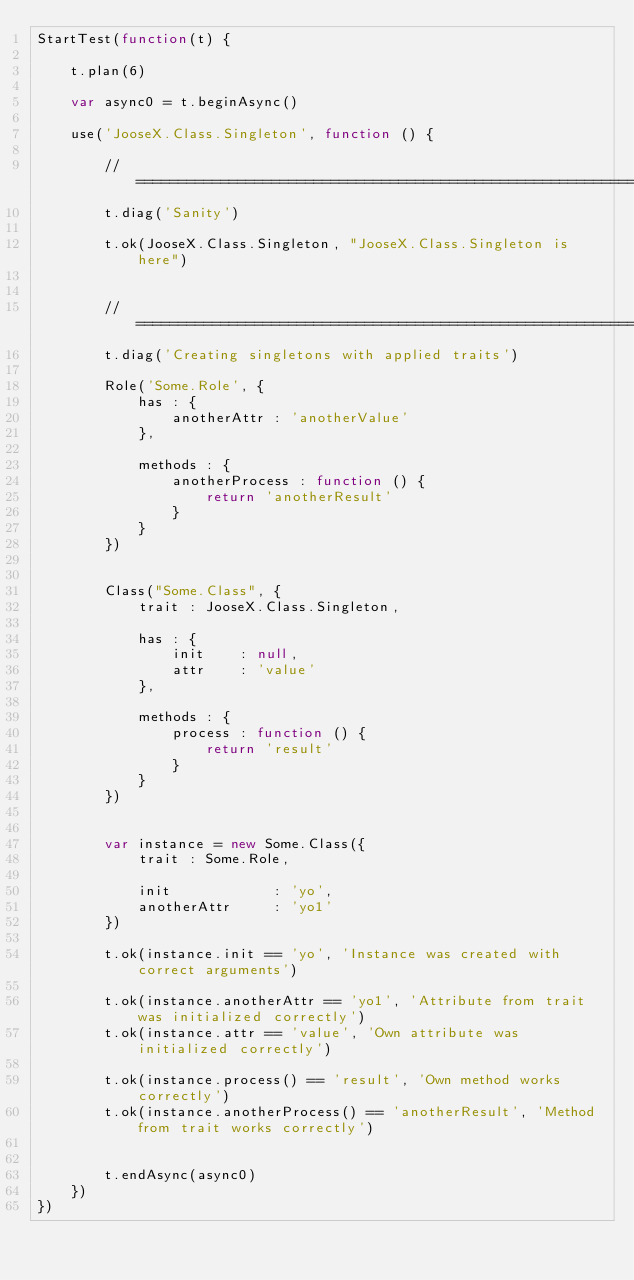<code> <loc_0><loc_0><loc_500><loc_500><_JavaScript_>StartTest(function(t) {
    
	t.plan(6)
    
    var async0 = t.beginAsync()
    
    use('JooseX.Class.Singleton', function () {
        
        //======================================================================================================================================================================================================================================================
        t.diag('Sanity')
        
        t.ok(JooseX.Class.Singleton, "JooseX.Class.Singleton is here")
        
        
        //======================================================================================================================================================================================================================================================
        t.diag('Creating singletons with applied traits')
        
        Role('Some.Role', {
            has : {
                anotherAttr : 'anotherValue'
            },
        
            methods : {
                anotherProcess : function () {
                    return 'anotherResult'
                }
            }
        })
        
        
        Class("Some.Class", {
            trait : JooseX.Class.Singleton,
            
            has : {
                init    : null,
                attr    : 'value'
            },
            
            methods : {
                process : function () {
                    return 'result'
                }
            }
        })
        
        
        var instance = new Some.Class({
            trait : Some.Role,
            
            init            : 'yo',
            anotherAttr     : 'yo1'
        })
        
        t.ok(instance.init == 'yo', 'Instance was created with correct arguments')
        
        t.ok(instance.anotherAttr == 'yo1', 'Attribute from trait was initialized correctly')
        t.ok(instance.attr == 'value', 'Own attribute was initialized correctly')
        
        t.ok(instance.process() == 'result', 'Own method works correctly')
        t.ok(instance.anotherProcess() == 'anotherResult', 'Method from trait works correctly')
        

        t.endAsync(async0)
    })
})    </code> 